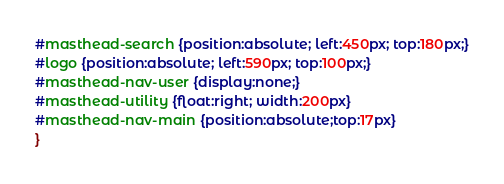Convert code to text. <code><loc_0><loc_0><loc_500><loc_500><_CSS_>#masthead-search {position:absolute; left:450px; top:180px;}
#logo {position:absolute; left:590px; top:100px;}
#masthead-nav-user {display:none;}
#masthead-utility {float:right; width:200px}
#masthead-nav-main {position:absolute;top:17px}
}</code> 